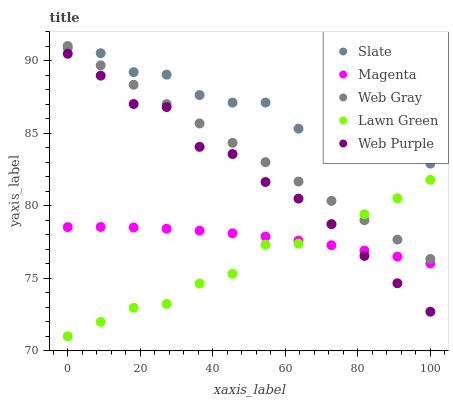Does Lawn Green have the minimum area under the curve?
Answer yes or no. Yes. Does Slate have the maximum area under the curve?
Answer yes or no. Yes. Does Web Gray have the minimum area under the curve?
Answer yes or no. No. Does Web Gray have the maximum area under the curve?
Answer yes or no. No. Is Web Gray the smoothest?
Answer yes or no. Yes. Is Slate the roughest?
Answer yes or no. Yes. Is Slate the smoothest?
Answer yes or no. No. Is Web Gray the roughest?
Answer yes or no. No. Does Lawn Green have the lowest value?
Answer yes or no. Yes. Does Web Gray have the lowest value?
Answer yes or no. No. Does Web Gray have the highest value?
Answer yes or no. Yes. Does Slate have the highest value?
Answer yes or no. No. Is Lawn Green less than Slate?
Answer yes or no. Yes. Is Web Gray greater than Web Purple?
Answer yes or no. Yes. Does Web Gray intersect Slate?
Answer yes or no. Yes. Is Web Gray less than Slate?
Answer yes or no. No. Is Web Gray greater than Slate?
Answer yes or no. No. Does Lawn Green intersect Slate?
Answer yes or no. No. 